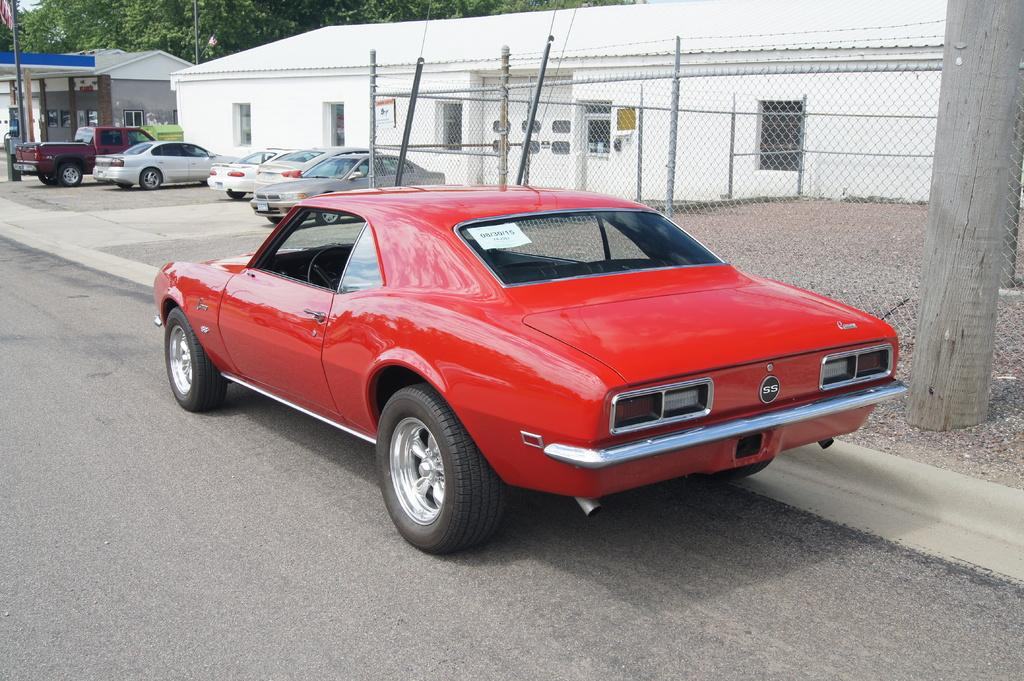What types of structures can be seen on the ground in the image? There are vehicles, houses, and a shed visible on the ground in the image. What type of pathway is present in the image? There is a road in the image. What is used to separate or enclose certain areas in the image? There is a fence in the image. What type of vegetation is present in the image? There are trees in the image. Can you see a tiger walking along the road in the image? No, there is no tiger present in the image. What key is used to unlock the shed in the image? There is no key mentioned or visible in the image, as it only shows the shed and not its locking mechanism. 